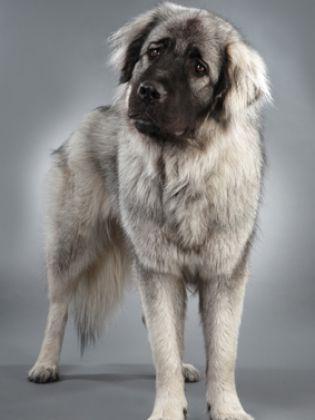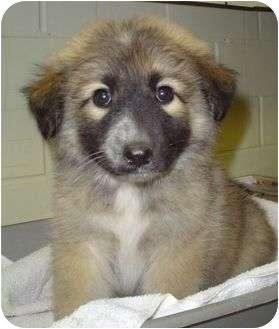The first image is the image on the left, the second image is the image on the right. For the images displayed, is the sentence "One of the photos shows one or more dogs outside in the snow." factually correct? Answer yes or no. No. The first image is the image on the left, the second image is the image on the right. Evaluate the accuracy of this statement regarding the images: "One image shows at least one dog on snowy ground.". Is it true? Answer yes or no. No. 